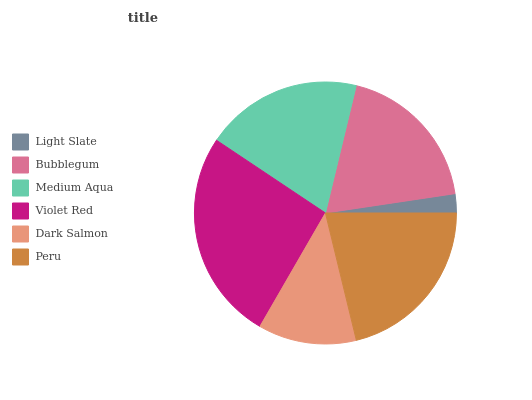Is Light Slate the minimum?
Answer yes or no. Yes. Is Violet Red the maximum?
Answer yes or no. Yes. Is Bubblegum the minimum?
Answer yes or no. No. Is Bubblegum the maximum?
Answer yes or no. No. Is Bubblegum greater than Light Slate?
Answer yes or no. Yes. Is Light Slate less than Bubblegum?
Answer yes or no. Yes. Is Light Slate greater than Bubblegum?
Answer yes or no. No. Is Bubblegum less than Light Slate?
Answer yes or no. No. Is Medium Aqua the high median?
Answer yes or no. Yes. Is Bubblegum the low median?
Answer yes or no. Yes. Is Light Slate the high median?
Answer yes or no. No. Is Dark Salmon the low median?
Answer yes or no. No. 